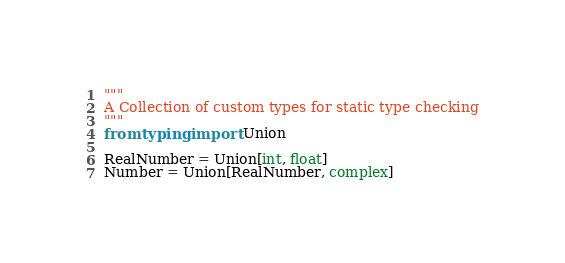<code> <loc_0><loc_0><loc_500><loc_500><_Python_>"""
A Collection of custom types for static type checking
"""
from typing import Union

RealNumber = Union[int, float]
Number = Union[RealNumber, complex]
</code> 